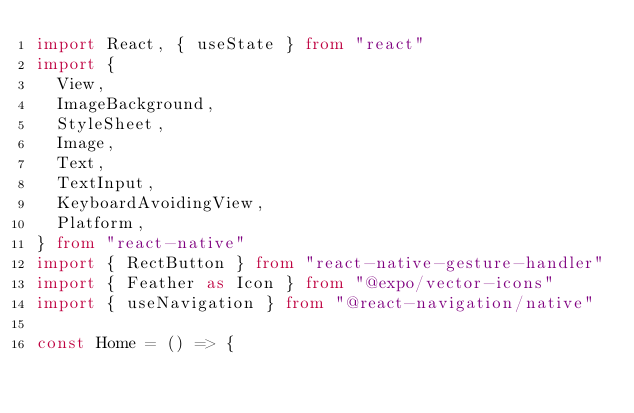<code> <loc_0><loc_0><loc_500><loc_500><_TypeScript_>import React, { useState } from "react"
import {
  View,
  ImageBackground,
  StyleSheet,
  Image,
  Text,
  TextInput,
  KeyboardAvoidingView,
  Platform,
} from "react-native"
import { RectButton } from "react-native-gesture-handler"
import { Feather as Icon } from "@expo/vector-icons"
import { useNavigation } from "@react-navigation/native"

const Home = () => {</code> 